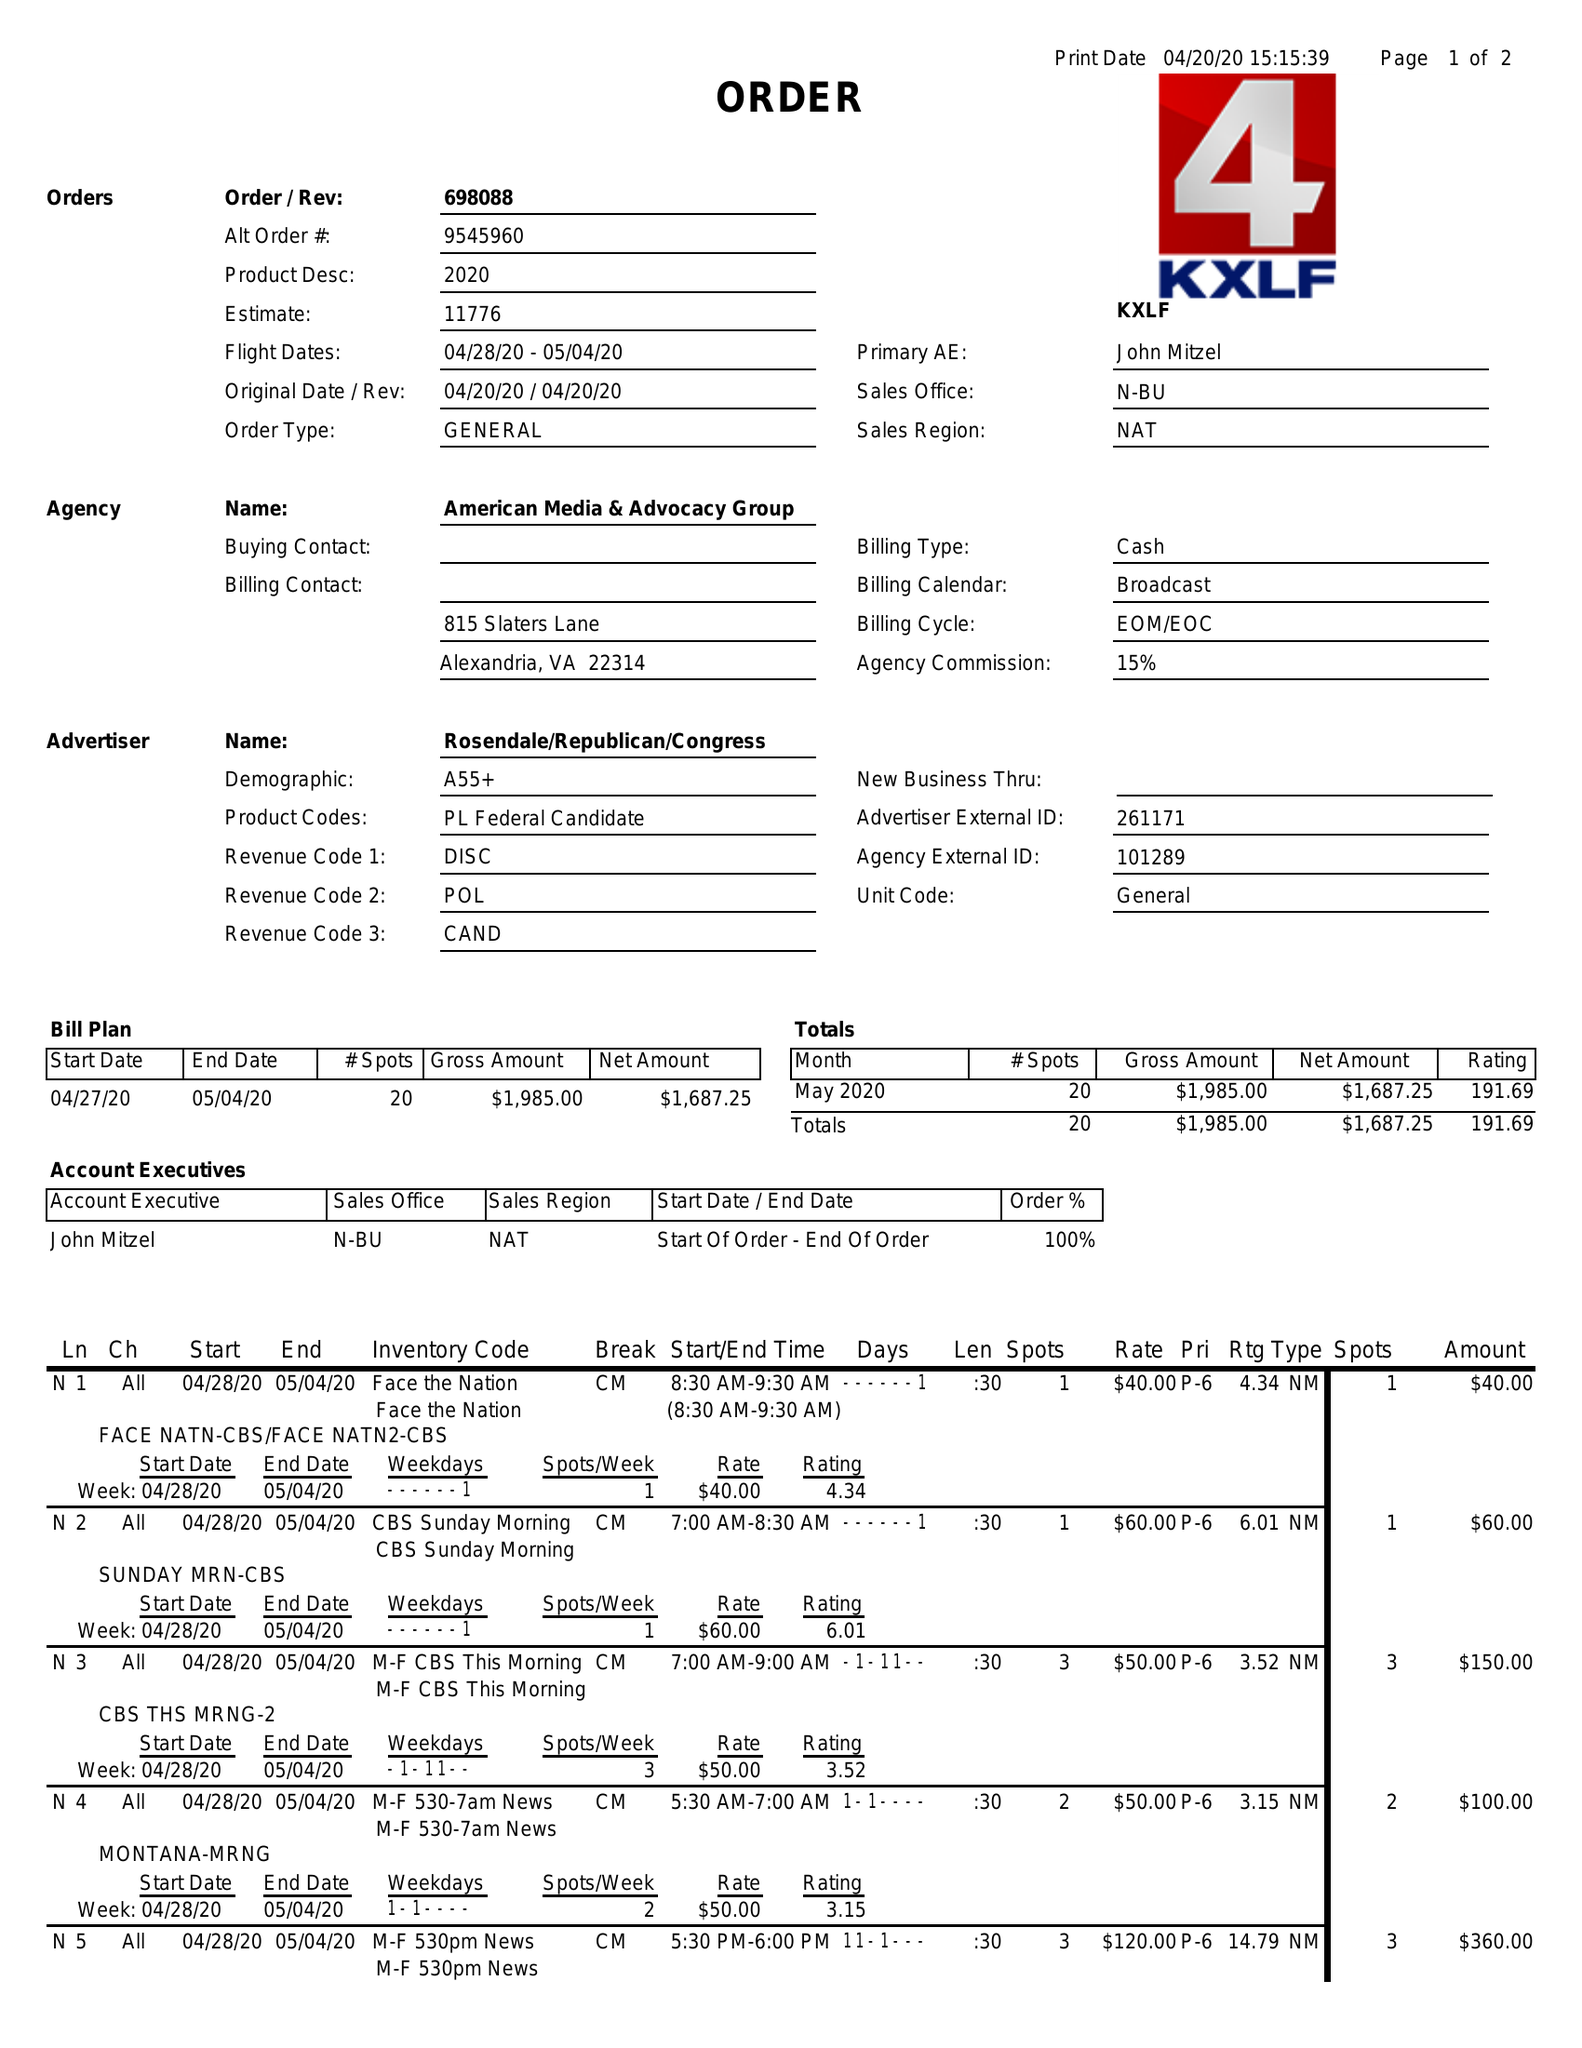What is the value for the flight_to?
Answer the question using a single word or phrase. 05/04/20 